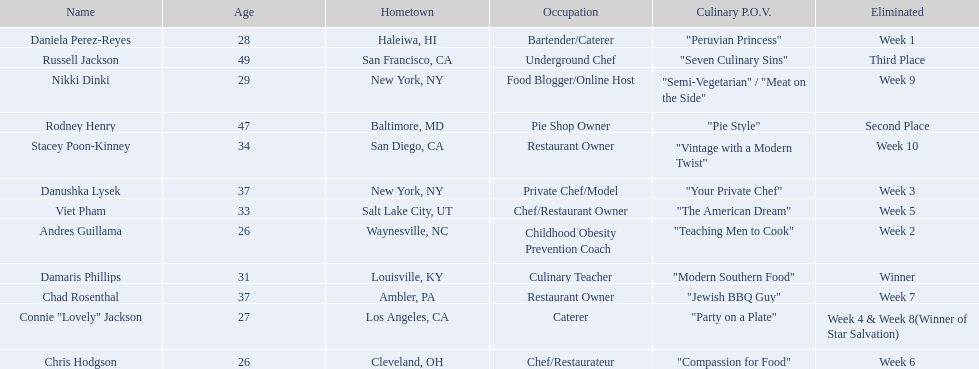Excluding the winner, and second and third place winners, who were the contestants eliminated? Stacey Poon-Kinney, Nikki Dinki, Chad Rosenthal, Chris Hodgson, Viet Pham, Connie "Lovely" Jackson, Danushka Lysek, Andres Guillama, Daniela Perez-Reyes. Of these contestants, who were the last five eliminated before the winner, second, and third place winners were announce? Stacey Poon-Kinney, Nikki Dinki, Chad Rosenthal, Chris Hodgson, Viet Pham. Of these five contestants, was nikki dinki or viet pham eliminated first? Viet Pham. 